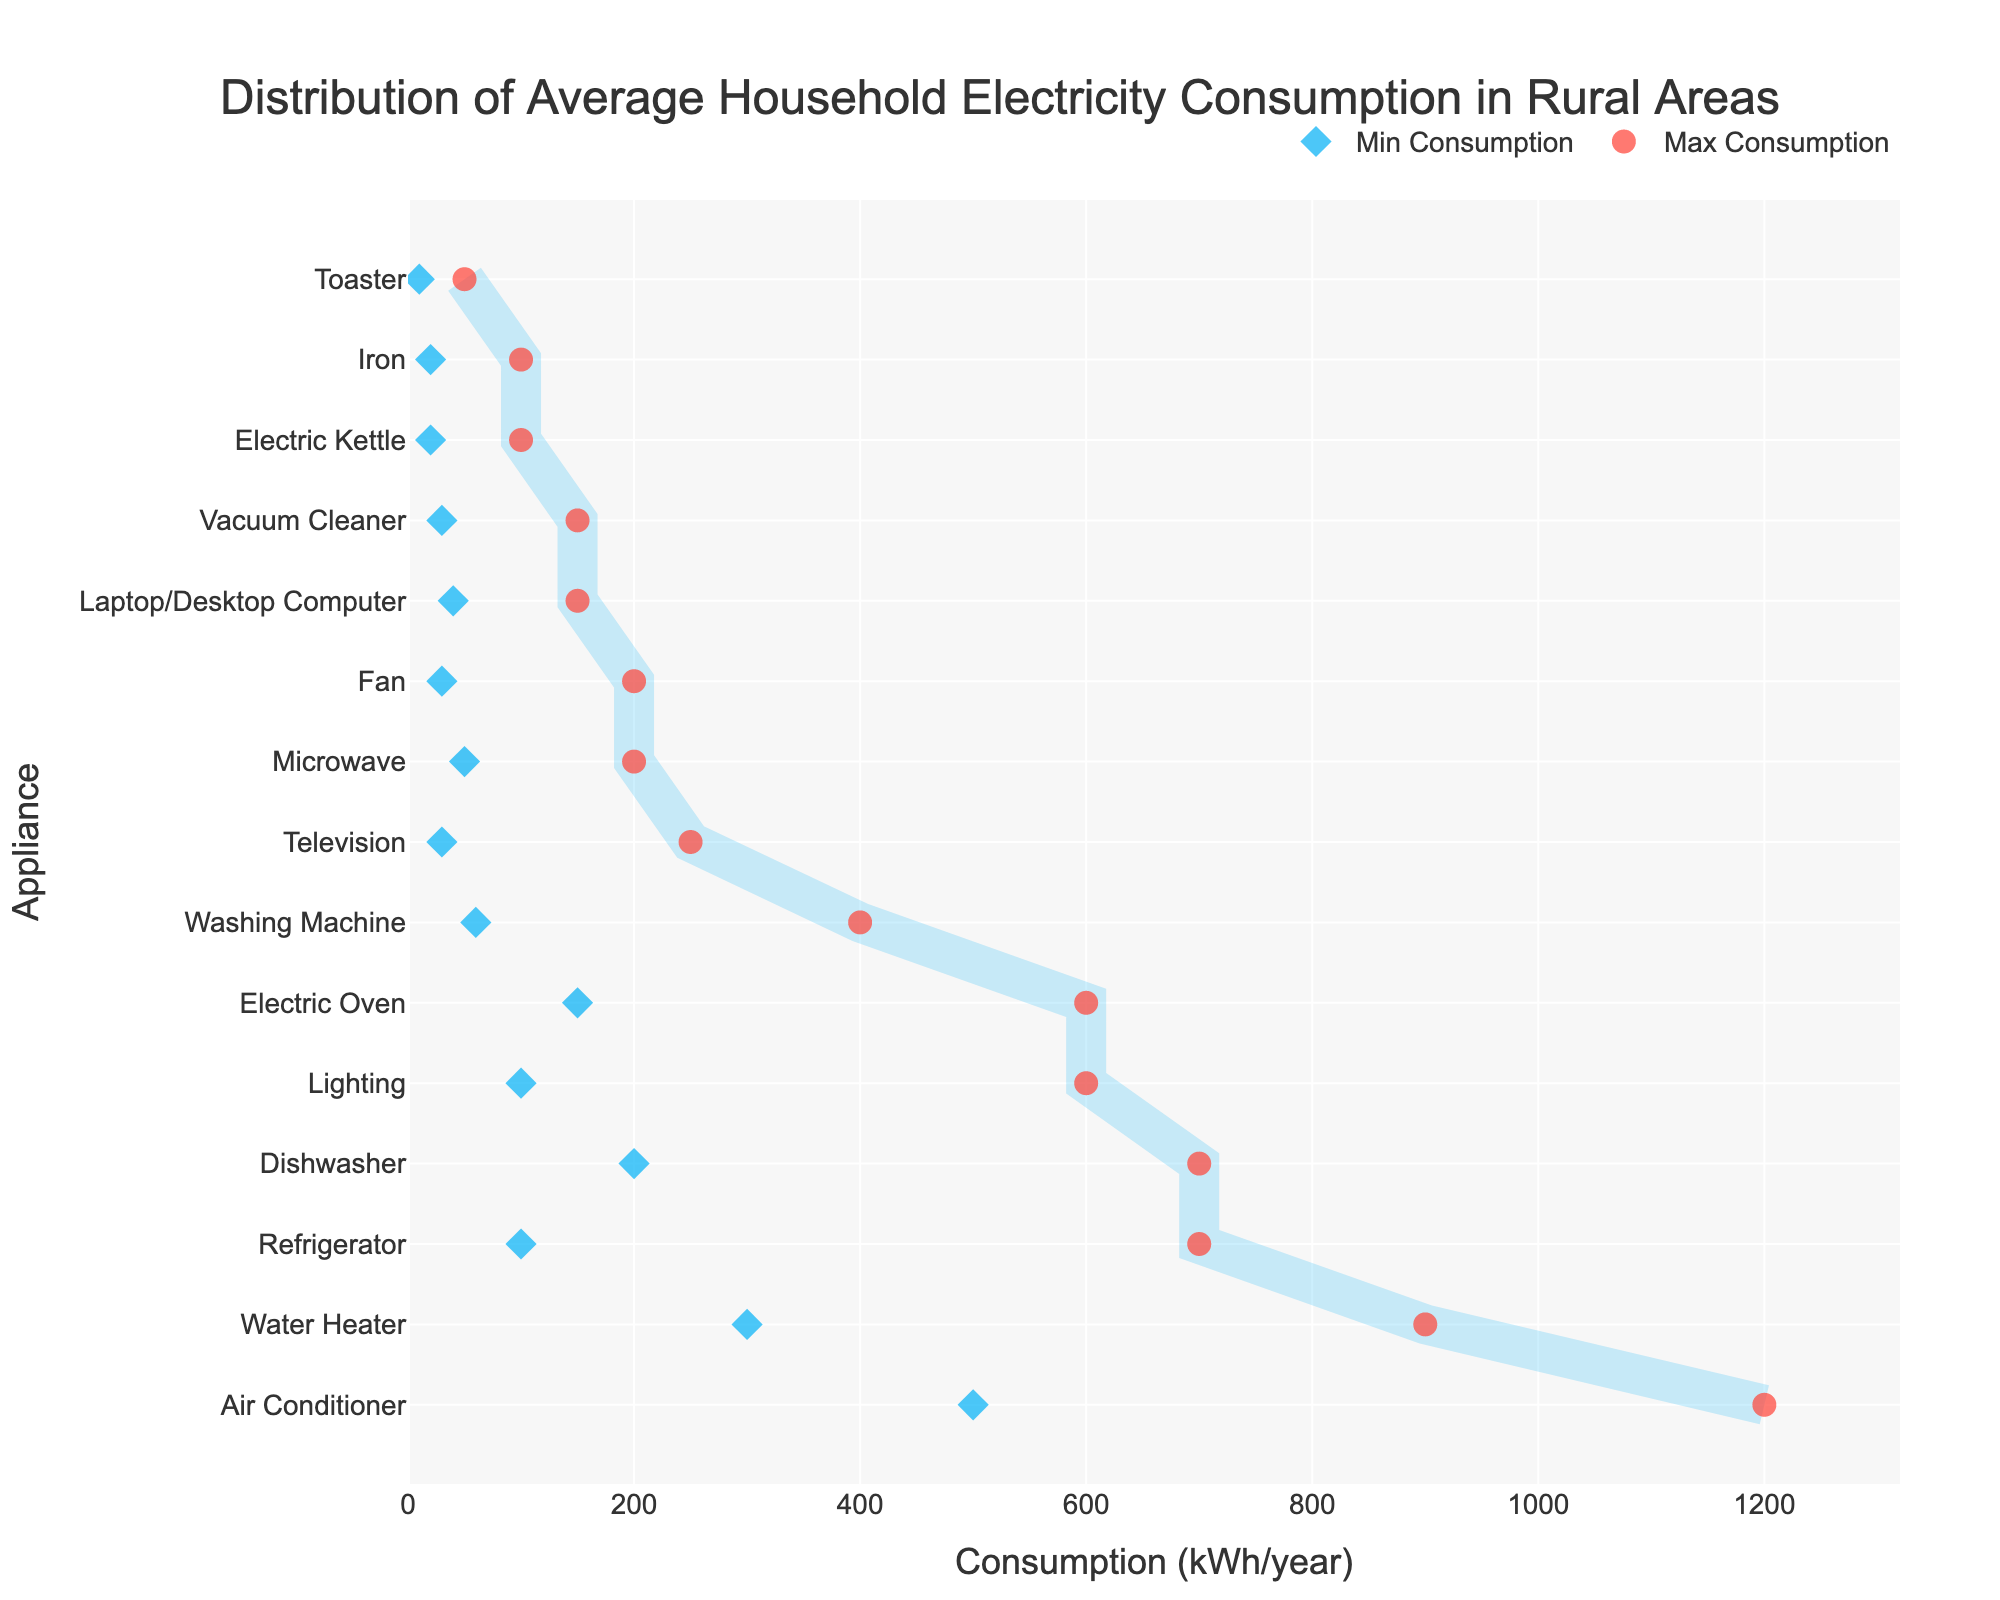What is the appliance with the highest maximum electricity consumption? The highest point on the x-axis corresponds to the appliance with the highest maximum electricity consumption. By observing, Air Conditioner has the highest maximum value of 1200 kWh/year.
Answer: Air Conditioner What is the range of electricity consumption for the washing machine? The range is calculated by subtracting the minimum value from the maximum value for the washing machine. The min is 60 kWh/year and the max is 400 kWh/year. Therefore, 400 - 60 = 340 kWh/year.
Answer: 340 kWh/year How many appliances have a maximum consumption of 700 kWh/year? By counting the appliances that reach up to 700 kWh/year on the x-axis, we see Refrigerator and Dishwasher both reach this level.
Answer: 2 appliances Which appliance uses less electricity: a laptop/desktop computer or a microwave? Compare the ranges of the laptop/desktop computer and the microwave. The laptop/desktop computer has a range of 40-150 kWh/year, while the microwave has a range of 50-200 kWh/year. The laptop/desktop computer uses less electricity overall.
Answer: Laptop/Desktop Computer What is the difference in maximum consumption between the water heater and the lighting? Water heater’s maximum consumption is 900 kWh/year, and lighting’s maximum consumption is 600 kWh/year. The difference is 900 - 600 = 300 kWh/year.
Answer: 300 kWh/year Which appliances have both their minimum and maximum consumption values below 100 kWh/year? Identify appliances where both min and max values are below 100. Toaster (10-50), Electric Kettle (20-100), and Iron (20-100) all fit these criteria.
Answer: Toaster, Electric Kettle, Iron What percentage of the maximum consumption of an air conditioner is the max consumption of a television? Calculate the percentage as (maximum of Television / maximum of Air Conditioner) * 100. This is (250 / 1200) * 100 = 20.83%.
Answer: 20.83% Which appliance has the smallest range of electricity consumption? By calculating the range (max - min) for each appliance, the smallest range is found for Toaster with (50 - 10) = 40 kWh/year.
Answer: Toaster Which two appliances have the closest maximum consumption values, and what are those values? By comparing the max consumption values, Refrigerator and Dishwasher both have a maximum of 700 kWh/year.
Answer: Refrigerator and Dishwasher, 700 kWh/year 